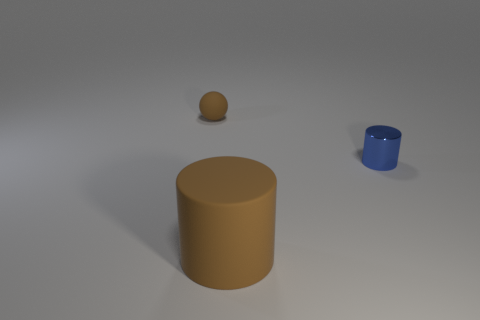Is there any other thing that has the same size as the brown cylinder?
Give a very brief answer. No. What is the thing that is behind the big brown cylinder and on the right side of the small brown matte ball made of?
Your response must be concise. Metal. There is a small thing right of the tiny ball; does it have the same color as the rubber object that is in front of the tiny brown matte object?
Ensure brevity in your answer.  No. How many brown things are either small things or big objects?
Your response must be concise. 2. Are there fewer large brown matte cylinders that are behind the big cylinder than big rubber objects that are behind the small rubber object?
Keep it short and to the point. No. Is there a brown object of the same size as the brown rubber cylinder?
Your answer should be compact. No. There is a brown rubber thing in front of the metallic object; is it the same size as the tiny brown matte ball?
Ensure brevity in your answer.  No. Are there more tiny blue shiny objects than matte cubes?
Make the answer very short. Yes. Are there any blue things of the same shape as the small brown rubber thing?
Keep it short and to the point. No. The brown matte object behind the large rubber object has what shape?
Your answer should be compact. Sphere. 